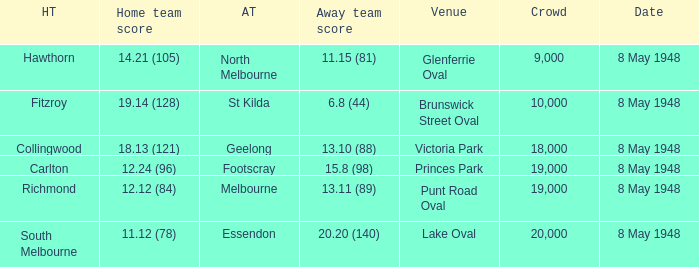Which away team has a home score of 14.21 (105)? North Melbourne. 